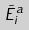Convert formula to latex. <formula><loc_0><loc_0><loc_500><loc_500>\tilde { E } _ { i } ^ { a }</formula> 